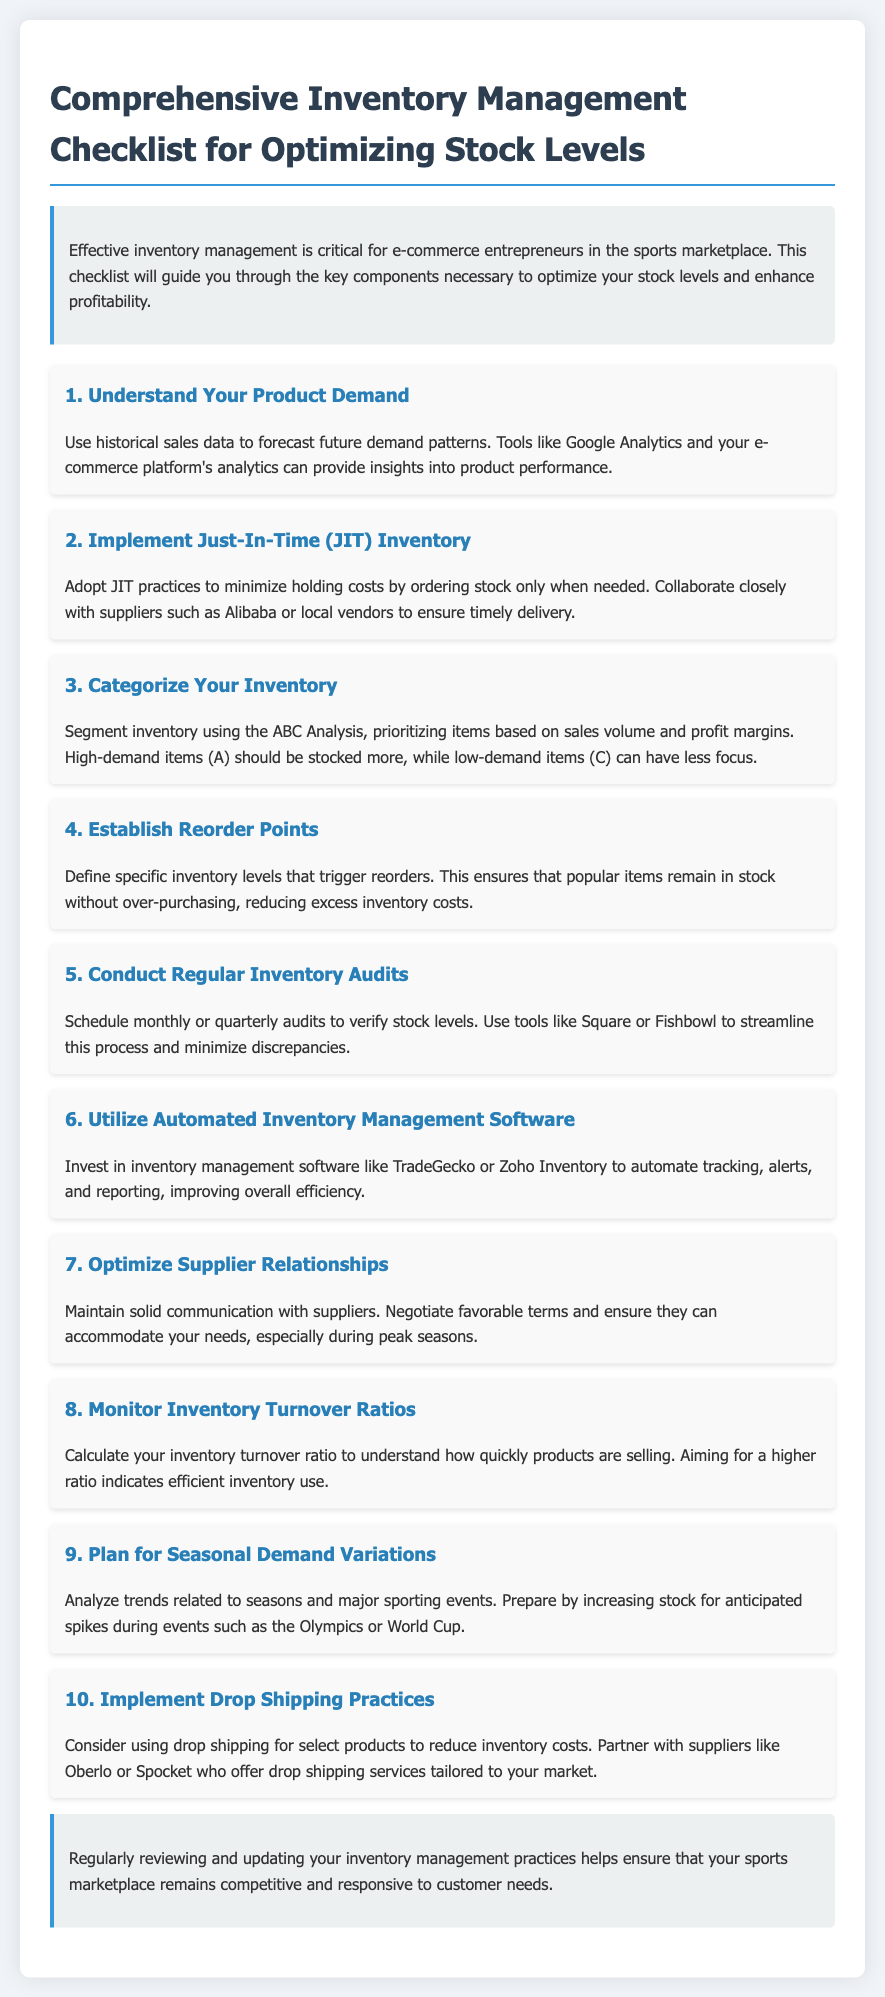What is the first item on the checklist? The first item discusses understanding product demand.
Answer: Understand Your Product Demand How many key components are listed in the checklist? The checklist has a total of ten items.
Answer: 10 What practice is recommended to minimize holding costs? This refers to the implementation of Just-In-Time inventory practices.
Answer: Just-In-Time (JIT) Inventory Which inventory analysis method is mentioned in the document? The document mentions the ABC Analysis for categorizing inventory.
Answer: ABC Analysis What does the document advise regarding inventory audits? It suggests conducting regular inventory audits on a monthly or quarterly basis.
Answer: Monthly or quarterly audits What ratio should be monitored to understand product sales speed? The inventory turnover ratio should be calculated.
Answer: Inventory Turnover Ratios Which tools are suggested for inventory management automation? The document recommends TradeGecko or Zoho Inventory.
Answer: TradeGecko or Zoho Inventory What should be analyzed to prepare for seasonal demand variations? The document advises analyzing trends related to seasons and major sporting events.
Answer: Trends related to seasons and major sporting events What is the purpose of establishing reorder points? Reorder points ensure that popular items remain in stock.
Answer: To ensure popular items remain in stock 